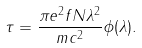<formula> <loc_0><loc_0><loc_500><loc_500>\tau = \frac { \pi e ^ { 2 } f N \lambda ^ { 2 } } { m c ^ { 2 } } \phi ( \lambda ) .</formula> 